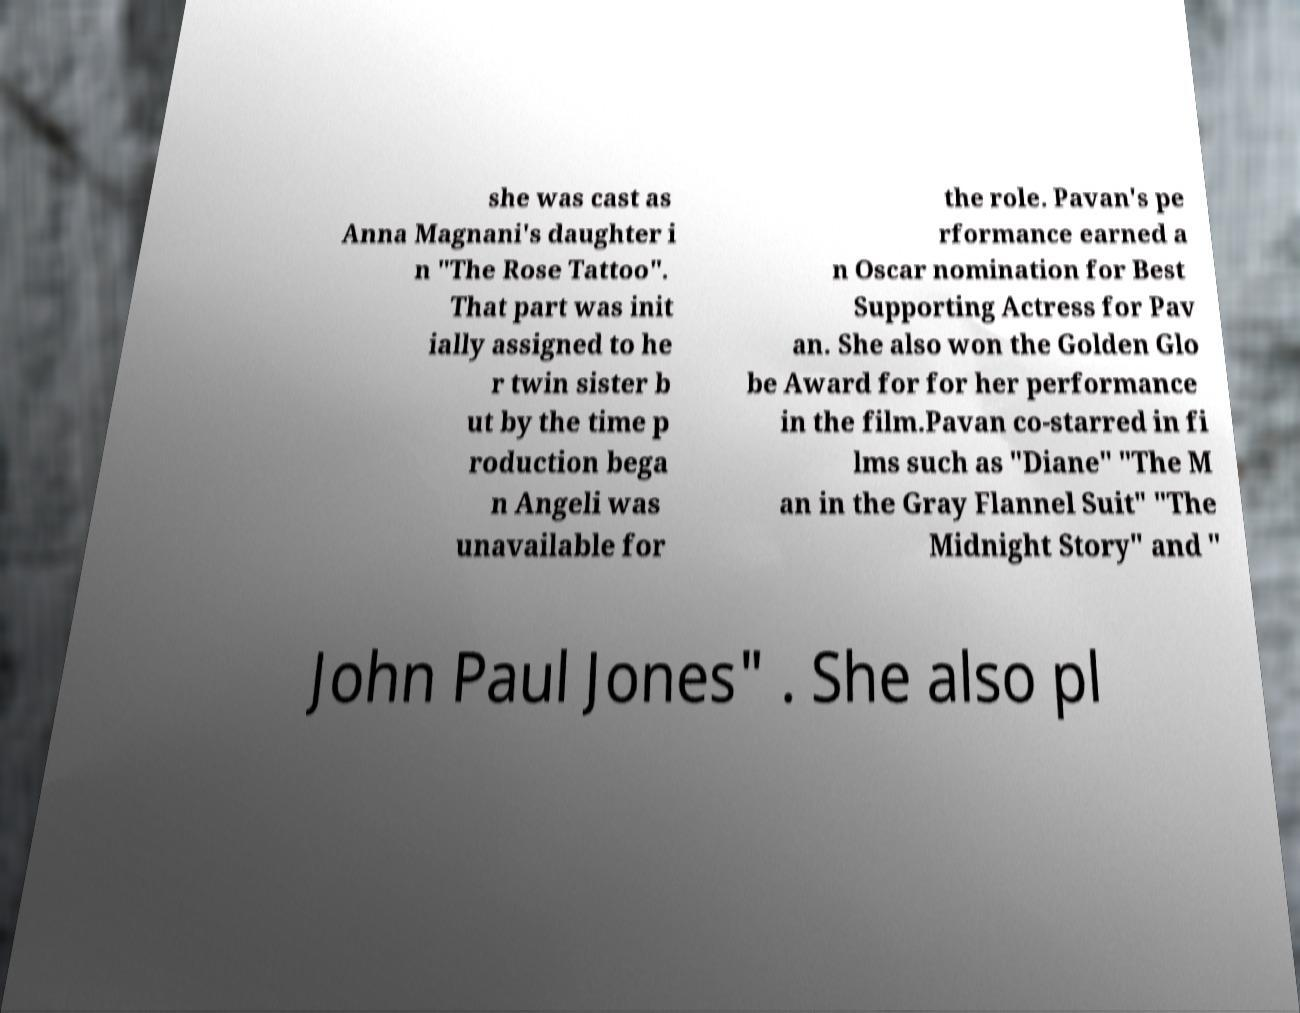Could you extract and type out the text from this image? she was cast as Anna Magnani's daughter i n "The Rose Tattoo". That part was init ially assigned to he r twin sister b ut by the time p roduction bega n Angeli was unavailable for the role. Pavan's pe rformance earned a n Oscar nomination for Best Supporting Actress for Pav an. She also won the Golden Glo be Award for for her performance in the film.Pavan co-starred in fi lms such as "Diane" "The M an in the Gray Flannel Suit" "The Midnight Story" and " John Paul Jones" . She also pl 